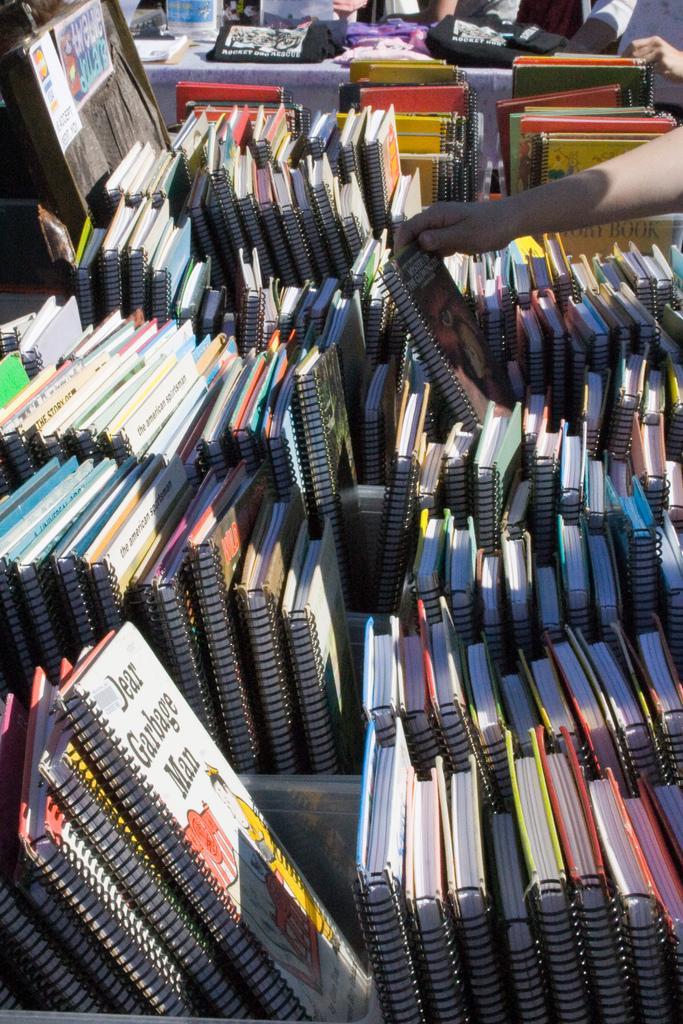Describe this image in one or two sentences. In this picture we can see a group of books, posters and some people holding books with their hands and in the background we can see some objects. 